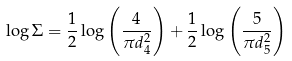<formula> <loc_0><loc_0><loc_500><loc_500>\log \Sigma = \frac { 1 } { 2 } \log \left ( \frac { 4 } { \pi d _ { 4 } ^ { 2 } } \right ) + \frac { 1 } { 2 } \log \left ( \frac { 5 } { \pi d _ { 5 } ^ { 2 } } \right )</formula> 